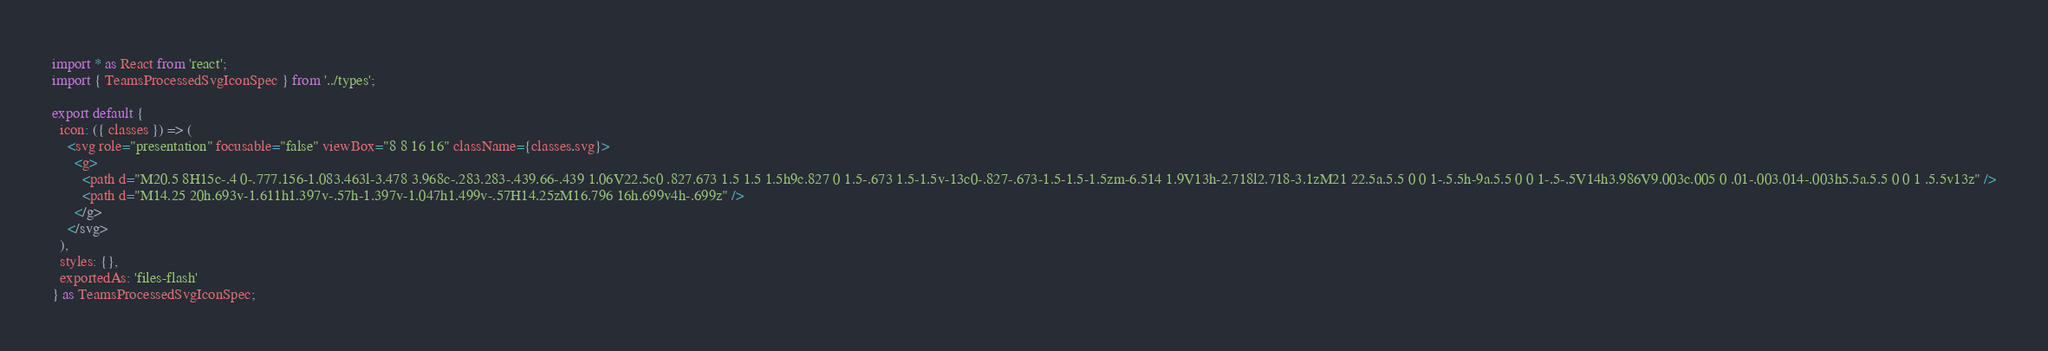Convert code to text. <code><loc_0><loc_0><loc_500><loc_500><_TypeScript_>import * as React from 'react';
import { TeamsProcessedSvgIconSpec } from '../types';

export default {
  icon: ({ classes }) => (
    <svg role="presentation" focusable="false" viewBox="8 8 16 16" className={classes.svg}>
      <g>
        <path d="M20.5 8H15c-.4 0-.777.156-1.083.463l-3.478 3.968c-.283.283-.439.66-.439 1.06V22.5c0 .827.673 1.5 1.5 1.5h9c.827 0 1.5-.673 1.5-1.5v-13c0-.827-.673-1.5-1.5-1.5zm-6.514 1.9V13h-2.718l2.718-3.1zM21 22.5a.5.5 0 0 1-.5.5h-9a.5.5 0 0 1-.5-.5V14h3.986V9.003c.005 0 .01-.003.014-.003h5.5a.5.5 0 0 1 .5.5v13z" />
        <path d="M14.25 20h.693v-1.611h1.397v-.57h-1.397v-1.047h1.499v-.57H14.25zM16.796 16h.699v4h-.699z" />
      </g>
    </svg>
  ),
  styles: {},
  exportedAs: 'files-flash'
} as TeamsProcessedSvgIconSpec;
</code> 